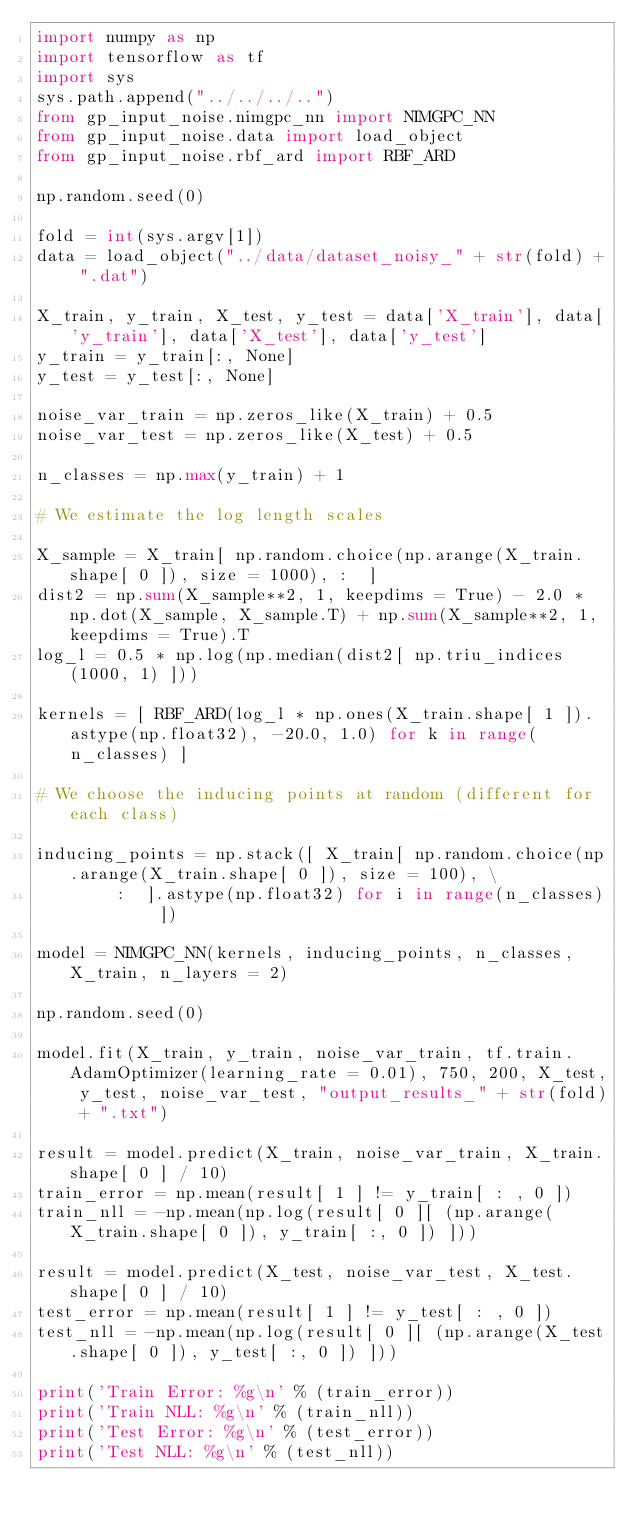<code> <loc_0><loc_0><loc_500><loc_500><_Python_>import numpy as np
import tensorflow as tf
import sys
sys.path.append("../../../..")
from gp_input_noise.nimgpc_nn import NIMGPC_NN
from gp_input_noise.data import load_object
from gp_input_noise.rbf_ard import RBF_ARD

np.random.seed(0)

fold = int(sys.argv[1])
data = load_object("../data/dataset_noisy_" + str(fold) + ".dat")

X_train, y_train, X_test, y_test = data['X_train'], data['y_train'], data['X_test'], data['y_test']
y_train = y_train[:, None]
y_test = y_test[:, None]

noise_var_train = np.zeros_like(X_train) + 0.5
noise_var_test = np.zeros_like(X_test) + 0.5

n_classes = np.max(y_train) + 1

# We estimate the log length scales

X_sample = X_train[ np.random.choice(np.arange(X_train.shape[ 0 ]), size = 1000), :  ]
dist2 = np.sum(X_sample**2, 1, keepdims = True) - 2.0 * np.dot(X_sample, X_sample.T) + np.sum(X_sample**2, 1, keepdims = True).T
log_l = 0.5 * np.log(np.median(dist2[ np.triu_indices(1000, 1) ]))

kernels = [ RBF_ARD(log_l * np.ones(X_train.shape[ 1 ]).astype(np.float32), -20.0, 1.0) for k in range(n_classes) ] 

# We choose the inducing points at random (different for each class)

inducing_points = np.stack([ X_train[ np.random.choice(np.arange(X_train.shape[ 0 ]), size = 100), \
        :  ].astype(np.float32) for i in range(n_classes) ])

model = NIMGPC_NN(kernels, inducing_points, n_classes, X_train, n_layers = 2)

np.random.seed(0)

model.fit(X_train, y_train, noise_var_train, tf.train.AdamOptimizer(learning_rate = 0.01), 750, 200, X_test, y_test, noise_var_test, "output_results_" + str(fold) + ".txt")

result = model.predict(X_train, noise_var_train, X_train.shape[ 0 ] / 10)
train_error = np.mean(result[ 1 ] != y_train[ : , 0 ]) 
train_nll = -np.mean(np.log(result[ 0 ][ (np.arange(X_train.shape[ 0 ]), y_train[ :, 0 ]) ]))

result = model.predict(X_test, noise_var_test, X_test.shape[ 0 ] / 10)
test_error = np.mean(result[ 1 ] != y_test[ : , 0 ]) 
test_nll = -np.mean(np.log(result[ 0 ][ (np.arange(X_test.shape[ 0 ]), y_test[ :, 0 ]) ]))

print('Train Error: %g\n' % (train_error))
print('Train NLL: %g\n' % (train_nll))
print('Test Error: %g\n' % (test_error))
print('Test NLL: %g\n' % (test_nll))


</code> 